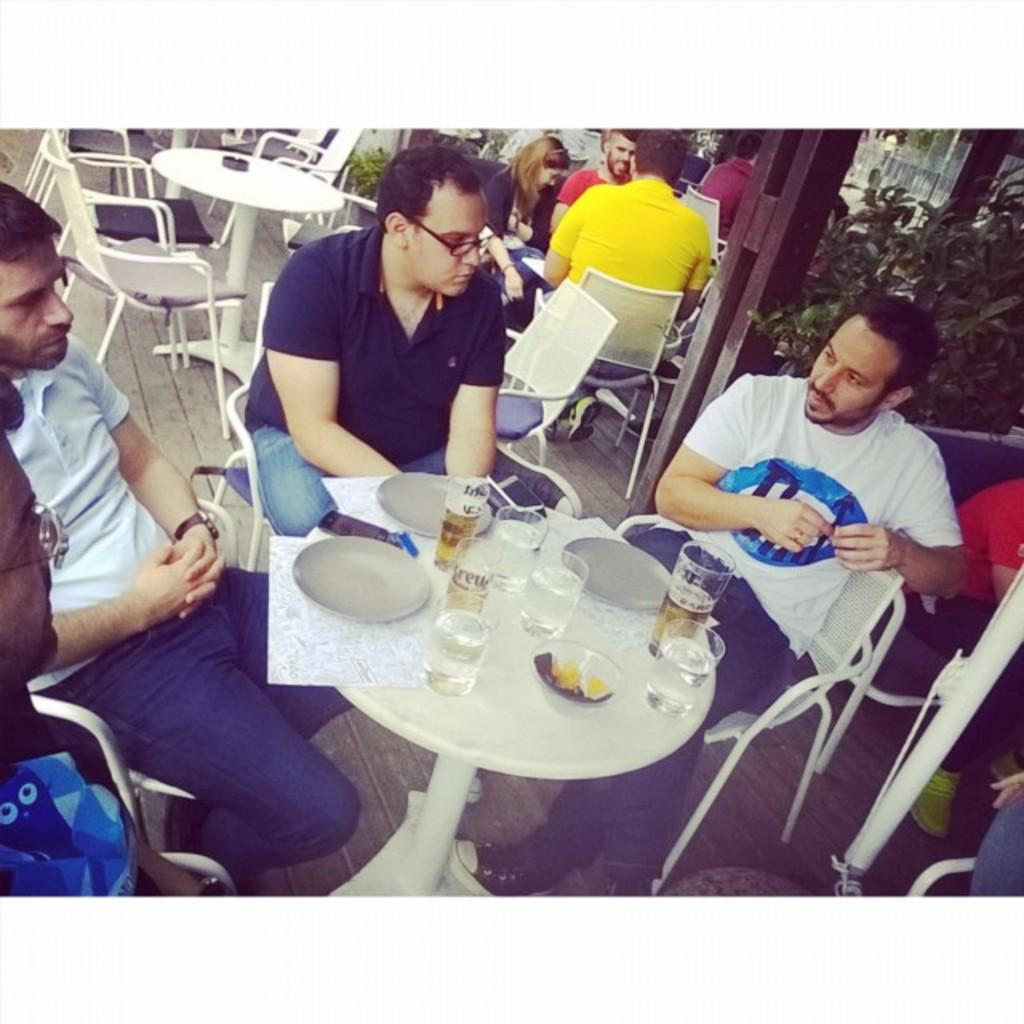How many people are in the image? There is a group of people in the image. What are the people in the image doing? The people are sitting together. What can be seen on the table in the image? There are wine glasses, plates, and other objects on the table. What is visible in the background of the image? There is a tree visible in the background of the image. How many pizzas are being delivered to the group in the image? There are no pizzas or delivery mentioned in the image; it only shows a group of people sitting together with wine glasses and plates on the table. What type of quartz can be seen on the table in the image? There is no quartz present on the table in the image. 